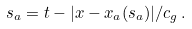<formula> <loc_0><loc_0><loc_500><loc_500>s _ { a } = t - | { x } - { x } _ { a } ( s _ { a } ) | / c _ { g } \, .</formula> 